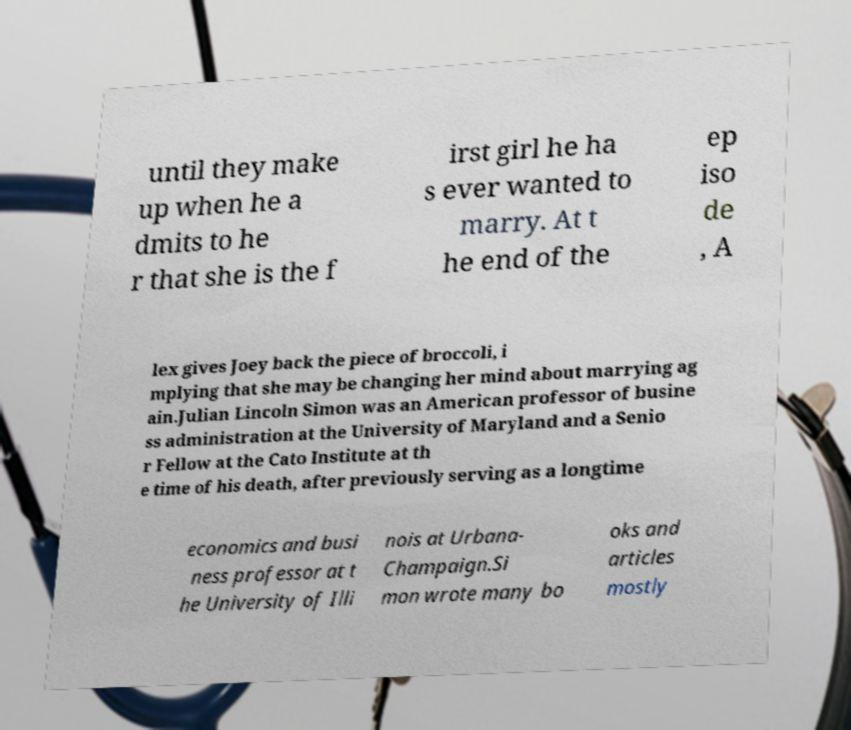Could you extract and type out the text from this image? until they make up when he a dmits to he r that she is the f irst girl he ha s ever wanted to marry. At t he end of the ep iso de , A lex gives Joey back the piece of broccoli, i mplying that she may be changing her mind about marrying ag ain.Julian Lincoln Simon was an American professor of busine ss administration at the University of Maryland and a Senio r Fellow at the Cato Institute at th e time of his death, after previously serving as a longtime economics and busi ness professor at t he University of Illi nois at Urbana- Champaign.Si mon wrote many bo oks and articles mostly 